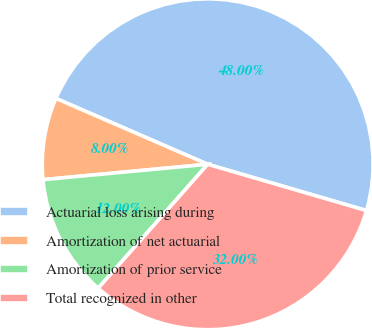<chart> <loc_0><loc_0><loc_500><loc_500><pie_chart><fcel>Actuarial loss arising during<fcel>Amortization of net actuarial<fcel>Amortization of prior service<fcel>Total recognized in other<nl><fcel>48.0%<fcel>8.0%<fcel>12.0%<fcel>32.0%<nl></chart> 